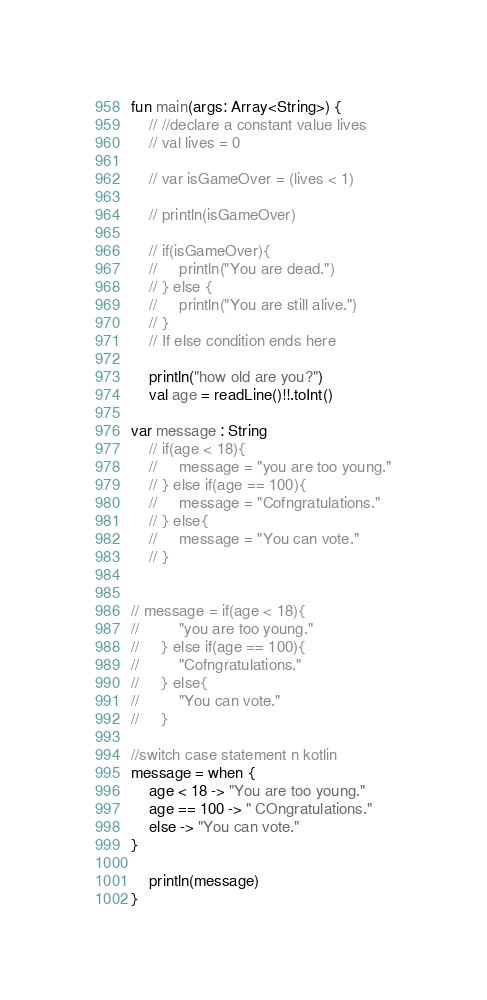Convert code to text. <code><loc_0><loc_0><loc_500><loc_500><_Kotlin_>fun main(args: Array<String>) {
    // //declare a constant value lives
    // val lives = 0

    // var isGameOver = (lives < 1)

    // println(isGameOver)

    // if(isGameOver){
    //     println("You are dead.")
    // } else {
    //     println("You are still alive.")
    // }
    // If else condition ends here

    println("how old are you?")
    val age = readLine()!!.toInt()

var message : String
    // if(age < 18){
    //     message = "you are too young."
    // } else if(age == 100){
    //     message = "Cofngratulations."
    // } else{
    //     message = "You can vote."
    // }


// message = if(age < 18){
//         "you are too young."
//     } else if(age == 100){
//         "Cofngratulations."
//     } else{
//         "You can vote."
//     }

//switch case statement n kotlin
message = when {
    age < 18 -> "You are too young."
    age == 100 -> " COngratulations."
    else -> "You can vote."
}

    println(message)
}</code> 